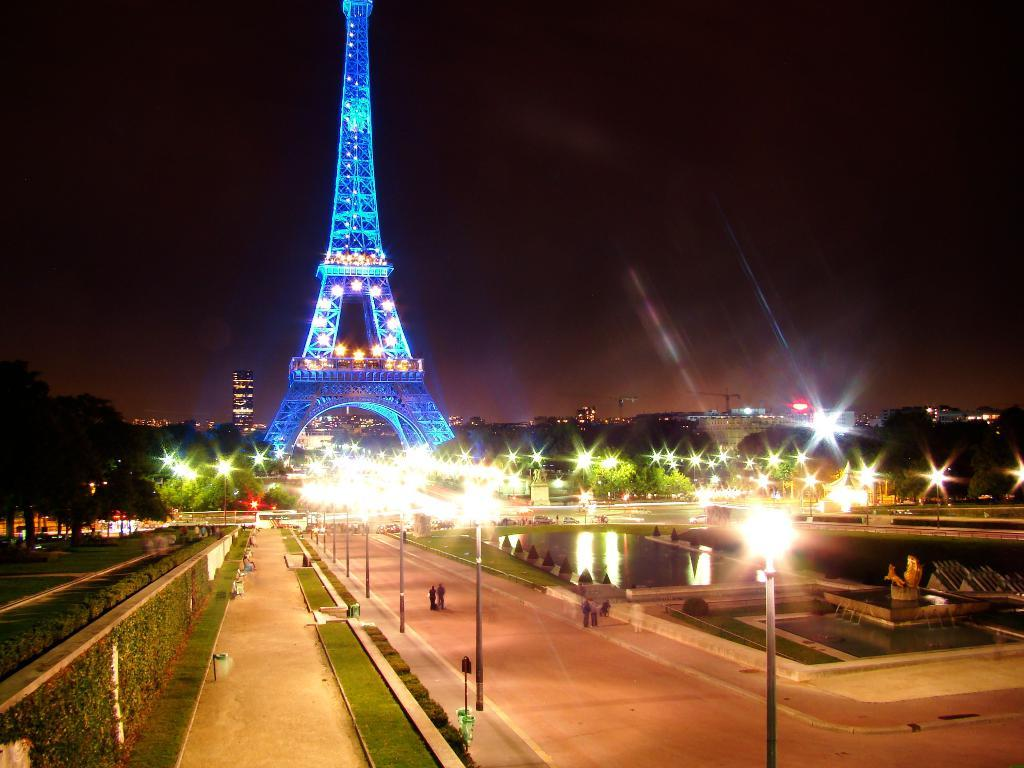What type of infrastructure can be seen in the image? There are roads and walls visible in the image. What natural elements are present in the image? There is grass, water, and trees visible in the image. What man-made structure is prominently featured in the image? The Eiffel Tower is present in the image, with lights. What type of lighting is present in the image? There are light poles visible in the image. What is the condition of the sky in the background of the image? The sky in the background is dark. Can you tell me how many apples are hanging from the light poles in the image? There are no apples present on the light poles in the image. What type of acoustics can be heard coming from the buildings in the image? There is no information about sounds or acoustics in the image, so it cannot be determined. 